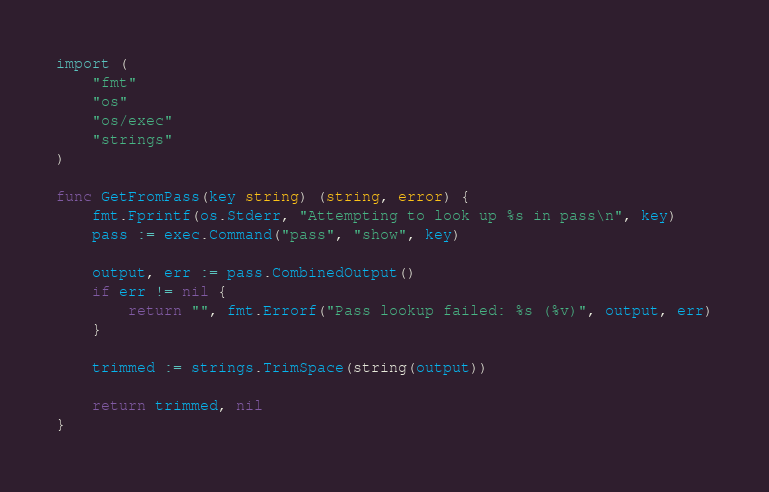<code> <loc_0><loc_0><loc_500><loc_500><_Go_>
import (
	"fmt"
	"os"
	"os/exec"
	"strings"
)

func GetFromPass(key string) (string, error) {
	fmt.Fprintf(os.Stderr, "Attempting to look up %s in pass\n", key)
	pass := exec.Command("pass", "show", key)

	output, err := pass.CombinedOutput()
	if err != nil {
		return "", fmt.Errorf("Pass lookup failed: %s (%v)", output, err)
	}

	trimmed := strings.TrimSpace(string(output))

	return trimmed, nil
}
</code> 